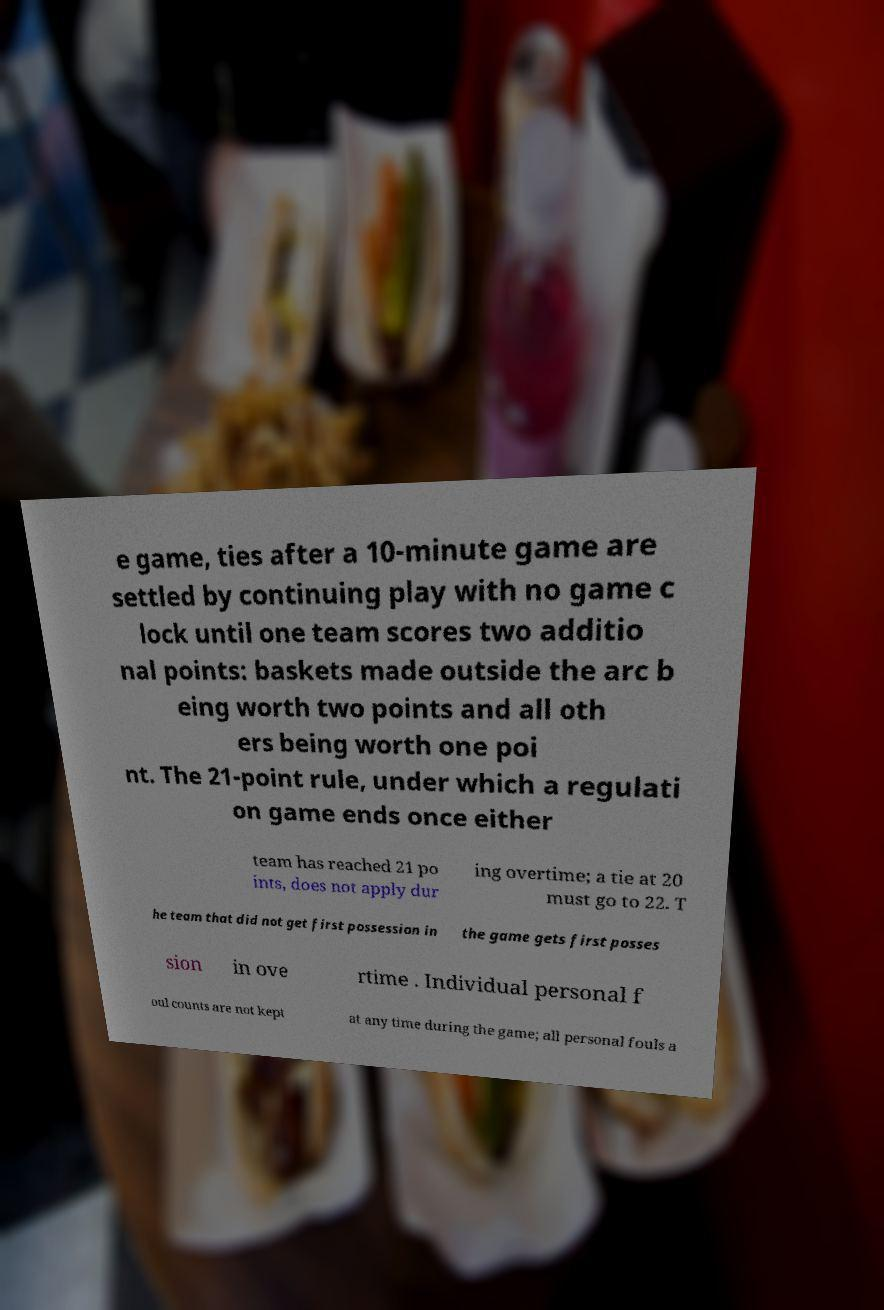Please read and relay the text visible in this image. What does it say? e game, ties after a 10-minute game are settled by continuing play with no game c lock until one team scores two additio nal points: baskets made outside the arc b eing worth two points and all oth ers being worth one poi nt. The 21-point rule, under which a regulati on game ends once either team has reached 21 po ints, does not apply dur ing overtime; a tie at 20 must go to 22. T he team that did not get first possession in the game gets first posses sion in ove rtime . Individual personal f oul counts are not kept at any time during the game; all personal fouls a 